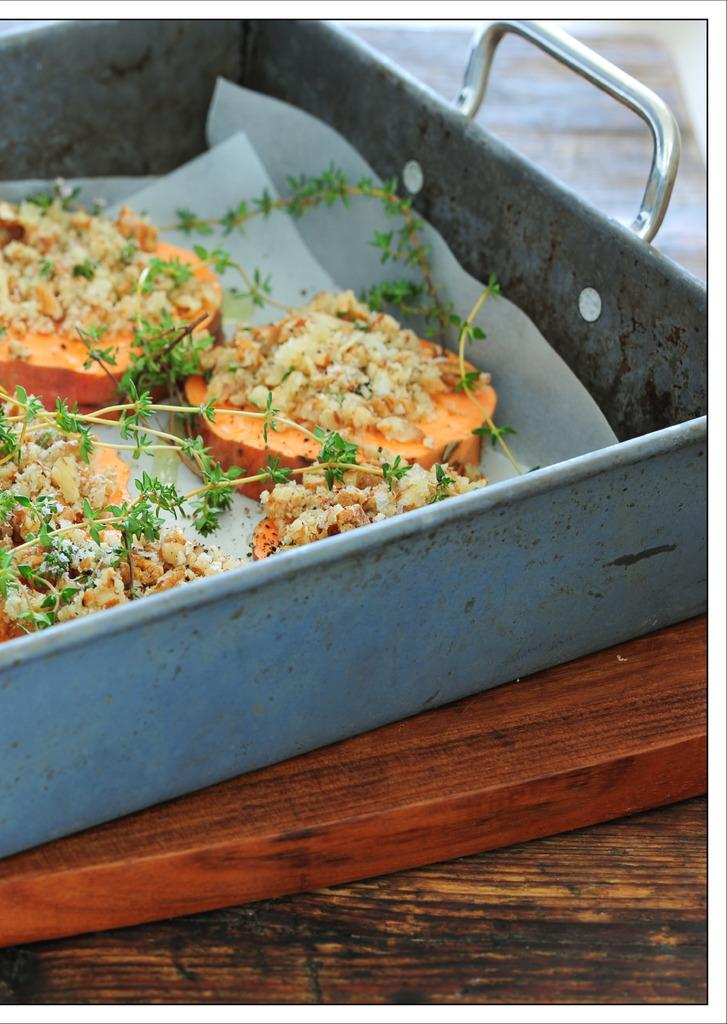What is in the tray that is visible in the image? There is food in the tray in the image. What other item can be seen in the image besides the tray? There is a paper in the image. What is on the table in the image? There is a board on the table in the image. What shape is the slave in the image? There is no slave present in the image, and therefore no shape can be determined. 